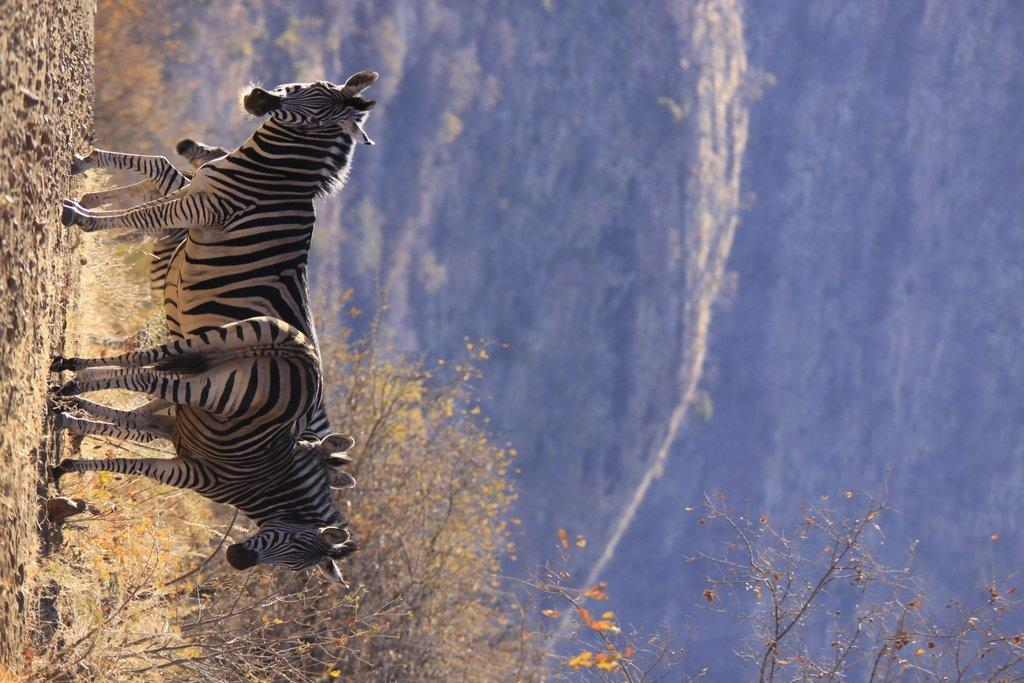What animals are standing on the land in the image? There are zebras standing on the land in the image. What type of vegetation is present at the bottom of the image? There are plants and trees at the bottom of the image. What can be seen in the background of the image? There is a hill in the background of the image. What is on the hill in the image? The hill has trees on it. What type of coat is hanging on the tree in the image? There is no coat present in the image; it features zebras, plants, trees, and a hill. Can you see a truck driving on the hill in the image? There is no truck present in the image; it only shows zebras, plants, trees, and a hill. 